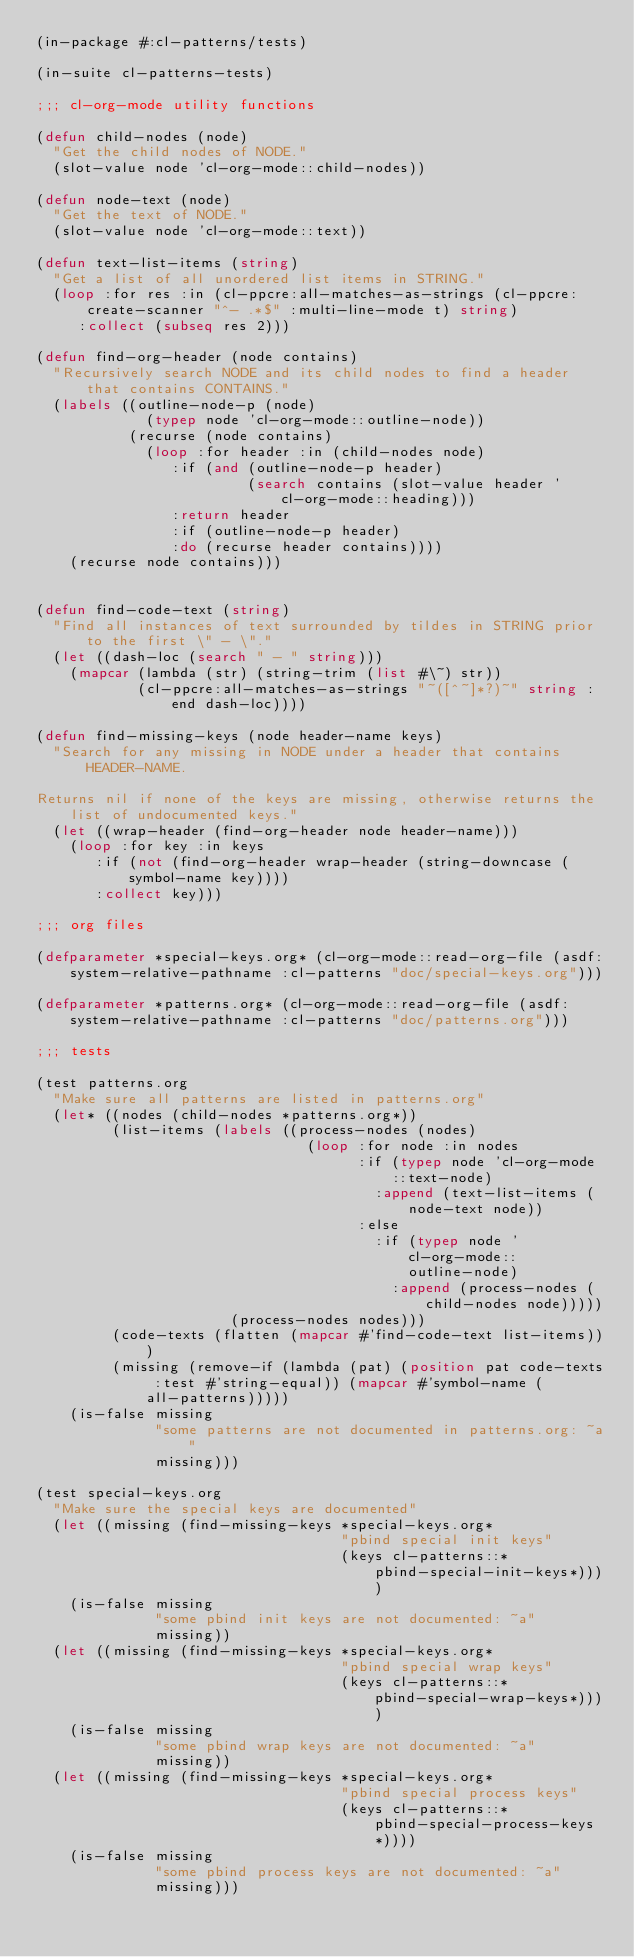<code> <loc_0><loc_0><loc_500><loc_500><_Lisp_>(in-package #:cl-patterns/tests)

(in-suite cl-patterns-tests)

;;; cl-org-mode utility functions

(defun child-nodes (node)
  "Get the child nodes of NODE."
  (slot-value node 'cl-org-mode::child-nodes))

(defun node-text (node)
  "Get the text of NODE."
  (slot-value node 'cl-org-mode::text))

(defun text-list-items (string)
  "Get a list of all unordered list items in STRING."
  (loop :for res :in (cl-ppcre:all-matches-as-strings (cl-ppcre:create-scanner "^- .*$" :multi-line-mode t) string)
     :collect (subseq res 2)))

(defun find-org-header (node contains)
  "Recursively search NODE and its child nodes to find a header that contains CONTAINS."
  (labels ((outline-node-p (node)
             (typep node 'cl-org-mode::outline-node))
           (recurse (node contains)
             (loop :for header :in (child-nodes node)
                :if (and (outline-node-p header)
                         (search contains (slot-value header 'cl-org-mode::heading)))
                :return header
                :if (outline-node-p header)
                :do (recurse header contains))))
    (recurse node contains)))


(defun find-code-text (string)
  "Find all instances of text surrounded by tildes in STRING prior to the first \" - \"."
  (let ((dash-loc (search " - " string)))
    (mapcar (lambda (str) (string-trim (list #\~) str))
            (cl-ppcre:all-matches-as-strings "~([^~]*?)~" string :end dash-loc))))

(defun find-missing-keys (node header-name keys)
  "Search for any missing in NODE under a header that contains HEADER-NAME.

Returns nil if none of the keys are missing, otherwise returns the list of undocumented keys."
  (let ((wrap-header (find-org-header node header-name)))
    (loop :for key :in keys
       :if (not (find-org-header wrap-header (string-downcase (symbol-name key))))
       :collect key)))

;;; org files

(defparameter *special-keys.org* (cl-org-mode::read-org-file (asdf:system-relative-pathname :cl-patterns "doc/special-keys.org")))

(defparameter *patterns.org* (cl-org-mode::read-org-file (asdf:system-relative-pathname :cl-patterns "doc/patterns.org")))

;;; tests

(test patterns.org
  "Make sure all patterns are listed in patterns.org"
  (let* ((nodes (child-nodes *patterns.org*))
         (list-items (labels ((process-nodes (nodes)
                                (loop :for node :in nodes
                                      :if (typep node 'cl-org-mode::text-node)
                                        :append (text-list-items (node-text node))
                                      :else
                                        :if (typep node 'cl-org-mode::outline-node)
                                          :append (process-nodes (child-nodes node)))))
                       (process-nodes nodes)))
         (code-texts (flatten (mapcar #'find-code-text list-items)))
         (missing (remove-if (lambda (pat) (position pat code-texts :test #'string-equal)) (mapcar #'symbol-name (all-patterns)))))
    (is-false missing
              "some patterns are not documented in patterns.org: ~a"
              missing)))

(test special-keys.org
  "Make sure the special keys are documented"
  (let ((missing (find-missing-keys *special-keys.org*
                                    "pbind special init keys"
                                    (keys cl-patterns::*pbind-special-init-keys*))))
    (is-false missing
              "some pbind init keys are not documented: ~a"
              missing))
  (let ((missing (find-missing-keys *special-keys.org*
                                    "pbind special wrap keys"
                                    (keys cl-patterns::*pbind-special-wrap-keys*))))
    (is-false missing
              "some pbind wrap keys are not documented: ~a"
              missing))
  (let ((missing (find-missing-keys *special-keys.org*
                                    "pbind special process keys"
                                    (keys cl-patterns::*pbind-special-process-keys*))))
    (is-false missing
              "some pbind process keys are not documented: ~a"
              missing)))
</code> 